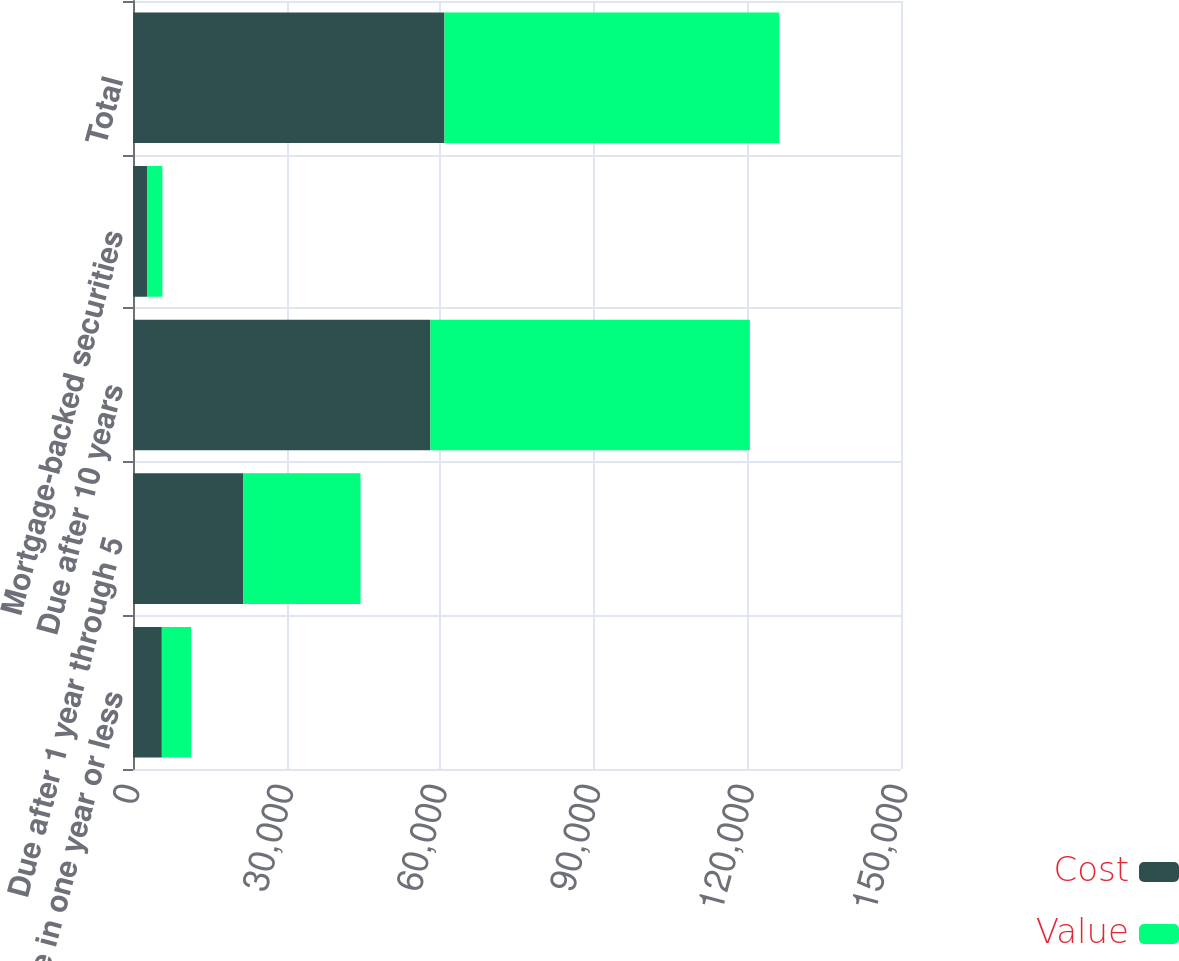Convert chart. <chart><loc_0><loc_0><loc_500><loc_500><stacked_bar_chart><ecel><fcel>Due in one year or less<fcel>Due after 1 year through 5<fcel>Due after 10 years<fcel>Mortgage-backed securities<fcel>Total<nl><fcel>Cost<fcel>5634<fcel>21498<fcel>58085<fcel>2744<fcel>60829<nl><fcel>Value<fcel>5719<fcel>22944<fcel>62396<fcel>2997<fcel>65393<nl></chart> 